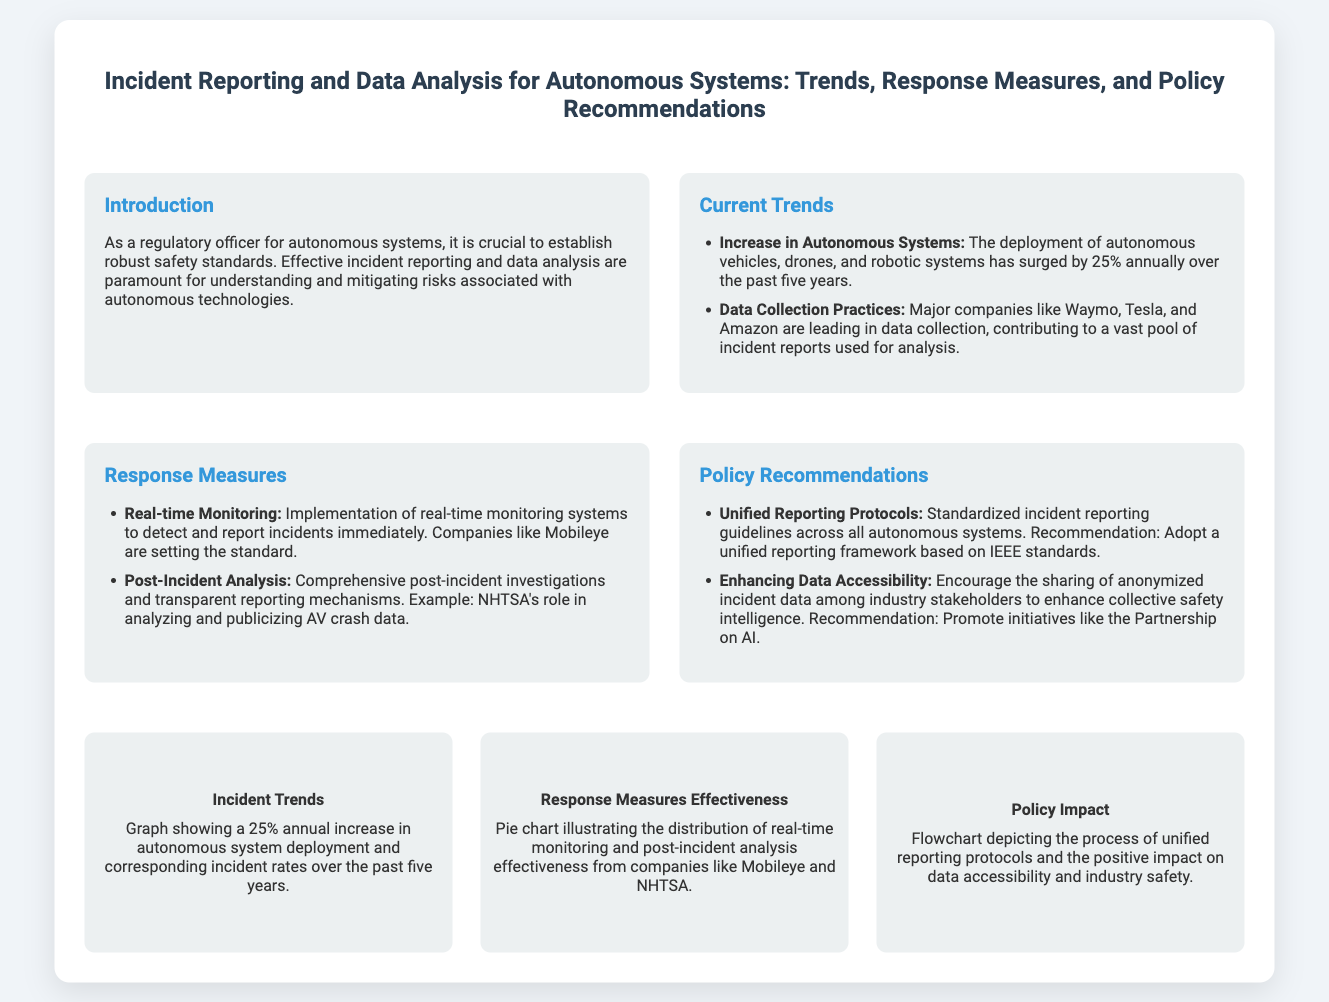what is the annual increase rate of autonomous system deployment? The document states that the deployment of autonomous systems has surged by 25% annually.
Answer: 25% who are the major companies leading in data collection practices? The slide mentions Waymo, Tesla, and Amazon as leading companies in data collection.
Answer: Waymo, Tesla, and Amazon what is one key response measure implemented for incident reporting? The document highlights real-time monitoring systems as an essential response measure.
Answer: Real-time monitoring what does NHTSA stand for? The acronym NHTSA is referenced in the context of post-incident analysis.
Answer: National Highway Traffic Safety Administration what standard is recommended for unified reporting protocols? The slide indicates a unified reporting framework based on IEEE standards.
Answer: IEEE standards which organization sets the standard for real-time monitoring effectiveness? Mobileye is mentioned in relation to setting standards for real-time monitoring.
Answer: Mobileye how are policy impacts illustrated in the infographic? The flowchart in the infographic depicts the process of unified reporting protocols.
Answer: Flowchart what is a recommended initiative for enhancing data accessibility? The document promotes initiatives like the Partnership on AI for data sharing.
Answer: Partnership on AI 